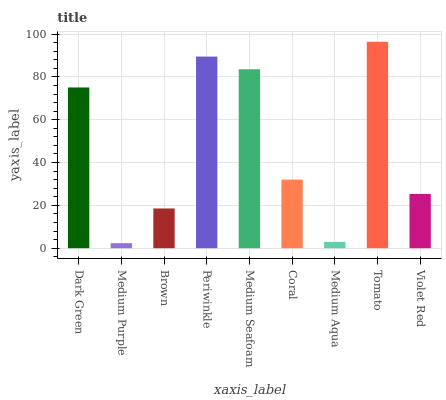Is Medium Purple the minimum?
Answer yes or no. Yes. Is Tomato the maximum?
Answer yes or no. Yes. Is Brown the minimum?
Answer yes or no. No. Is Brown the maximum?
Answer yes or no. No. Is Brown greater than Medium Purple?
Answer yes or no. Yes. Is Medium Purple less than Brown?
Answer yes or no. Yes. Is Medium Purple greater than Brown?
Answer yes or no. No. Is Brown less than Medium Purple?
Answer yes or no. No. Is Coral the high median?
Answer yes or no. Yes. Is Coral the low median?
Answer yes or no. Yes. Is Periwinkle the high median?
Answer yes or no. No. Is Medium Aqua the low median?
Answer yes or no. No. 